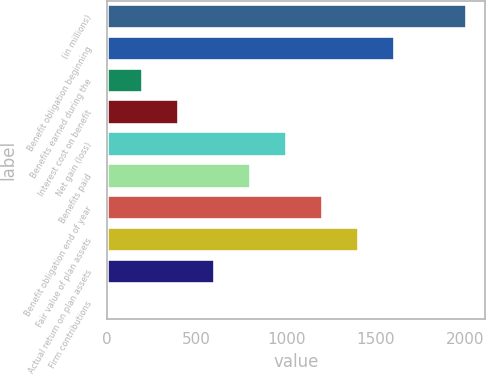<chart> <loc_0><loc_0><loc_500><loc_500><bar_chart><fcel>(in millions)<fcel>Benefit obligation beginning<fcel>Benefits earned during the<fcel>Interest cost on benefit<fcel>Net gain (loss)<fcel>Benefits paid<fcel>Benefit obligation end of year<fcel>Fair value of plan assets<fcel>Actual return on plan assets<fcel>Firm contributions<nl><fcel>2007<fcel>1606.2<fcel>203.4<fcel>403.8<fcel>1005<fcel>804.6<fcel>1205.4<fcel>1405.8<fcel>604.2<fcel>3<nl></chart> 